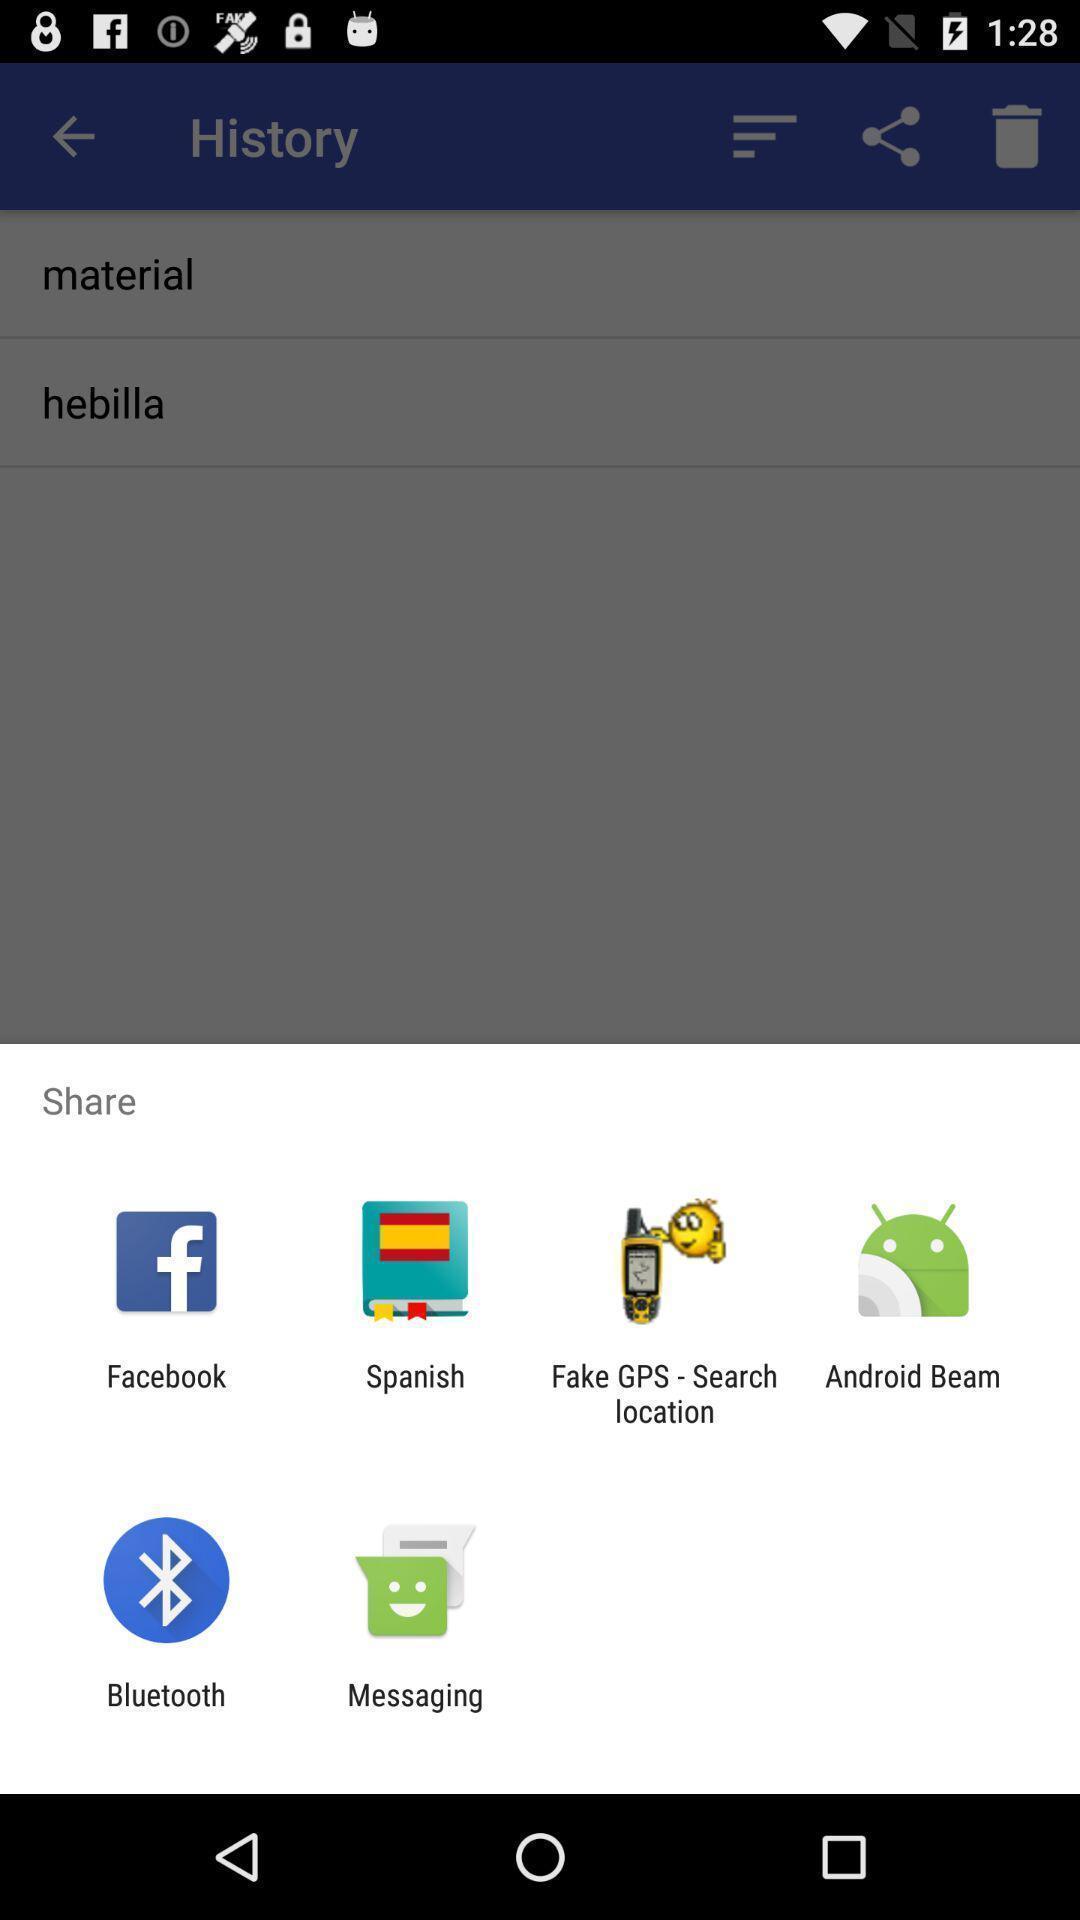Describe the visual elements of this screenshot. Screen displaying sharing options using different social applications. 